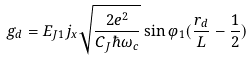<formula> <loc_0><loc_0><loc_500><loc_500>g _ { d } = E _ { J 1 } j _ { x } \sqrt { \frac { 2 e ^ { 2 } } { C _ { J } \hbar { \omega } _ { c } } } \sin \varphi _ { 1 } ( \frac { r _ { d } } { L } - \frac { 1 } { 2 } )</formula> 